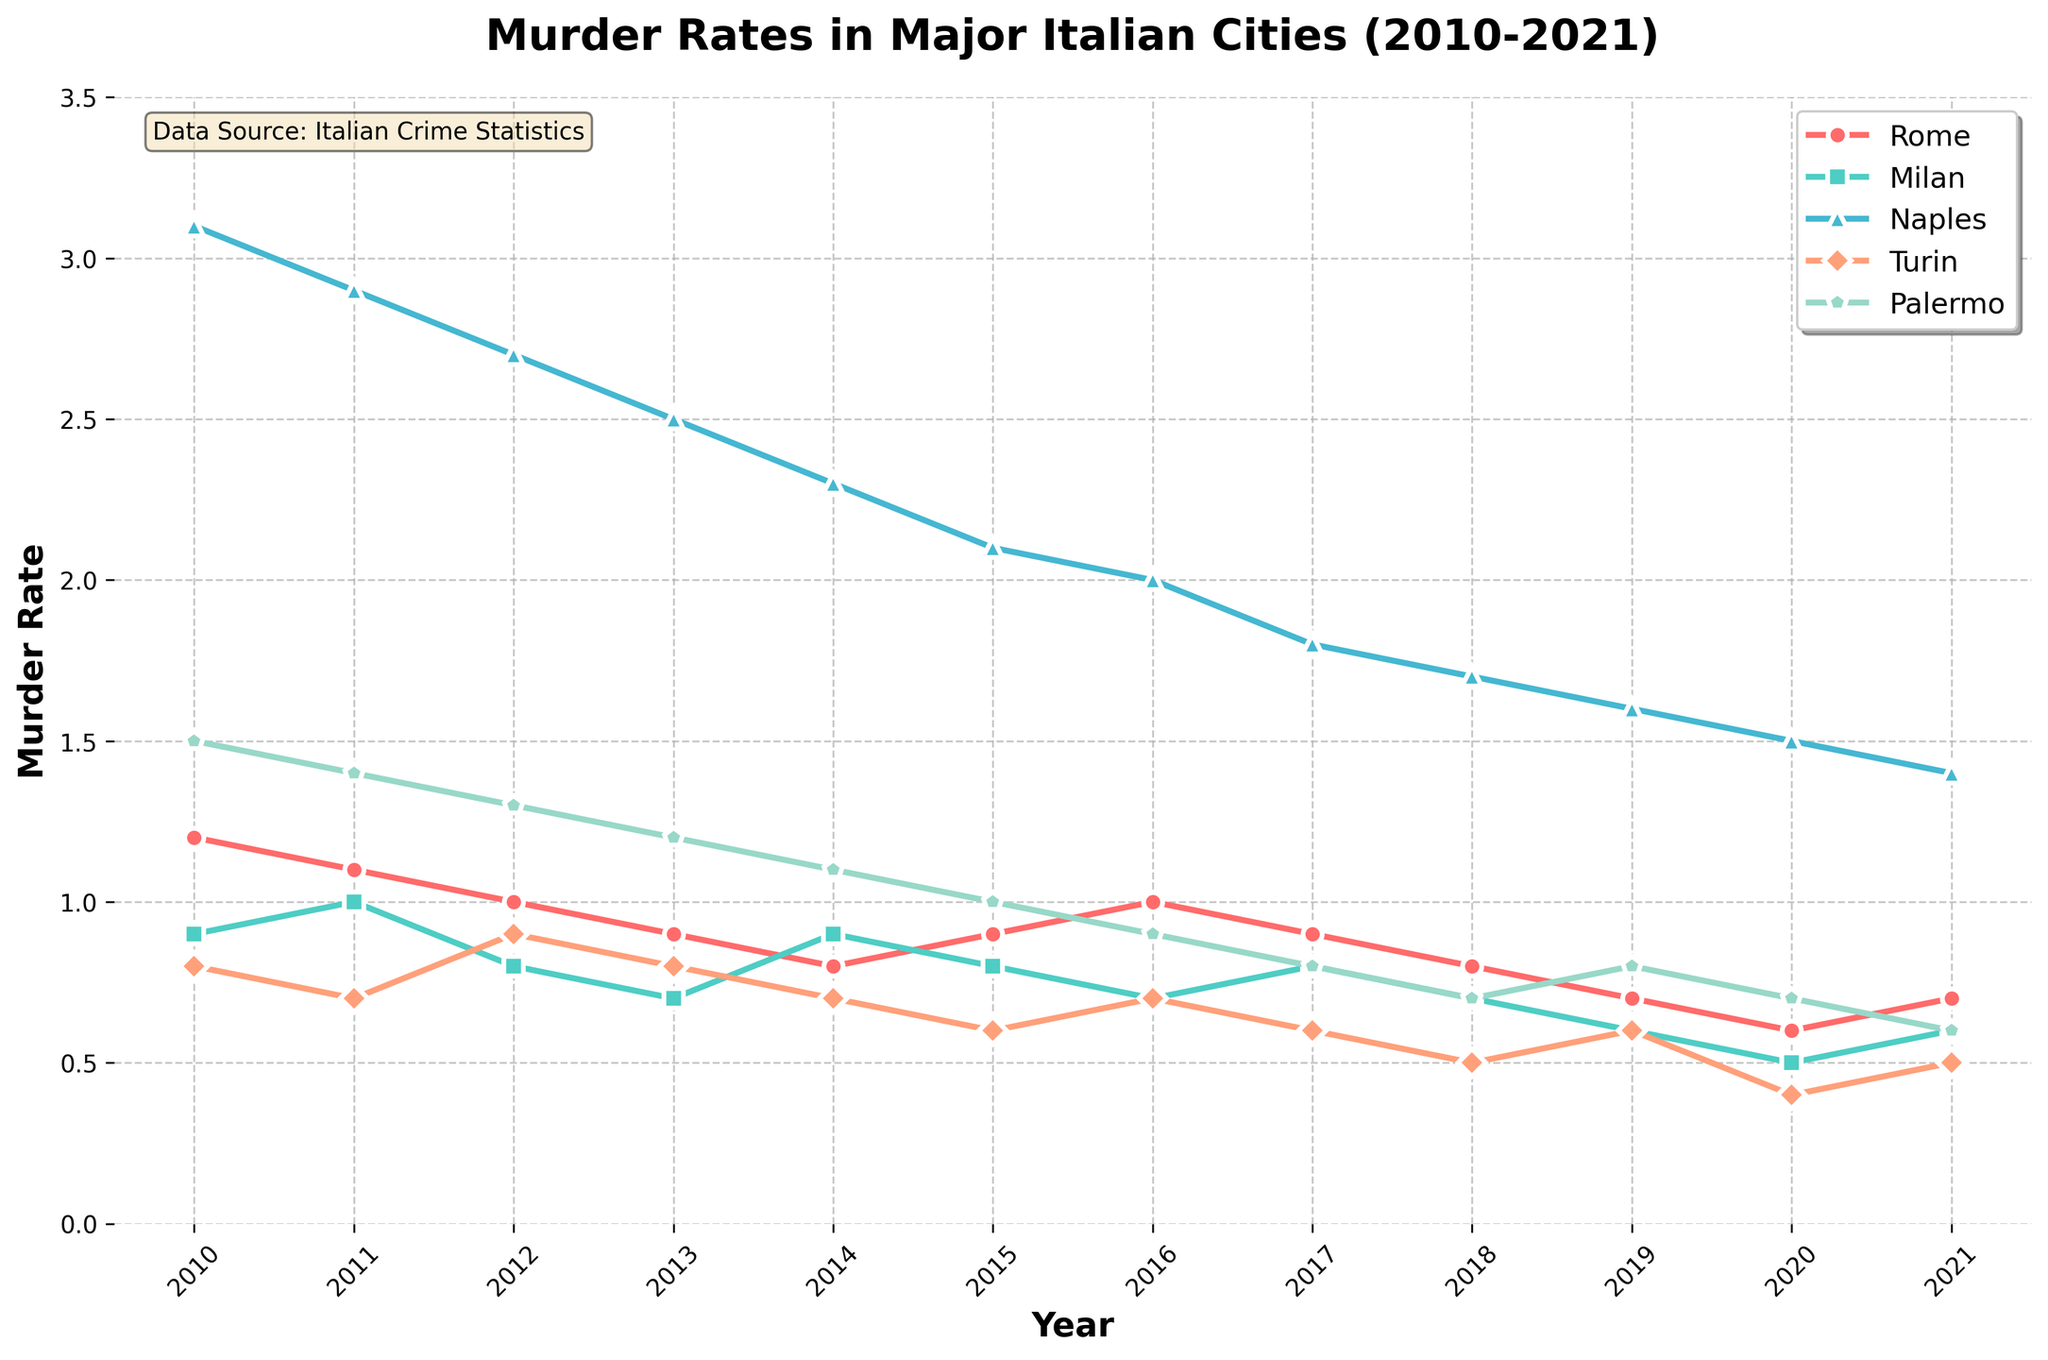How did the murder rate in Rome change from 2010 to 2021? To discern the change, look at the initial value in 2010 which is 1.2 and the final value in 2021 which is 0.7. Subtract the final value from the initial value: 1.2 - 0.7 = 0.5
Answer: Decreased by 0.5 Which city had the highest murder rate in 2015? Observe the plotted data for the year 2015. The highest point on the chart corresponds to Naples with a murder rate of 2.1
Answer: Naples By how much did the murder rate in Naples decrease from 2010 to 2021? The murder rate in Naples in 2010 was 3.1, and in 2021 it was 1.4. Subtract the value in 2021 from the value in 2010: 3.1 - 1.4 = 1.7
Answer: Decreased by 1.7 Which city showed the most consistent decline in murder rates between 2010 and 2021? Observe each city's trend lines on the chart. The line for Palermo shows a consistent, smooth decline from 1.5 to 0.6
Answer: Palermo Compare the murder rates of Milan and Turin in 2012. Which city had a higher rate and by how much? In 2012, Milan had a rate of 0.8 and Turin had a rate of 0.9. Subtract Milan's rate from Turin's rate: 0.9 - 0.8 = 0.1
Answer: Turin by 0.1 What is the average murder rate in Rome from 2010 to 2021? Add up all murder rate values for Rome from 2010 to 2021 and divide by the number of years (12). Sum = 1.2 + 1.1 + 1.0 + 0.9 + 0.8 + 0.9 + 1.0 + 0.9 + 0.8 + 0.7 + 0.6 + 0.7 = 10.6. Divide by 12: 10.6 / 12 ≈ 0.883
Answer: Approximately 0.883 In which year did Milan see a dip in the murder rate to 0.5? Look at the data points for Milan. The only year it dips to 0.5 is 2020
Answer: 2020 By comparing the trends for Turin and Palermo, which city had a more variable murder rate during the period 2010-2021? Observe the trend lines for Turin and Palermo. Turin had fluctuations whereas Palermo had a more steady decline
Answer: Turin How do the overall trends of murder rates in Naples compare to the other cities from 2010 to 2021? Analyze the slope of the lines. Naples has the steepest downward slope indicating a sharp decline, whereas other cities have gentler slopes
Answer: Steeper decline in Naples In what year did all cities except Naples have murder rates below 1.0? Check each city's data points for rates below 1.0. Only Naples remains above 1.0 while the others are below, in 2016
Answer: 2016 